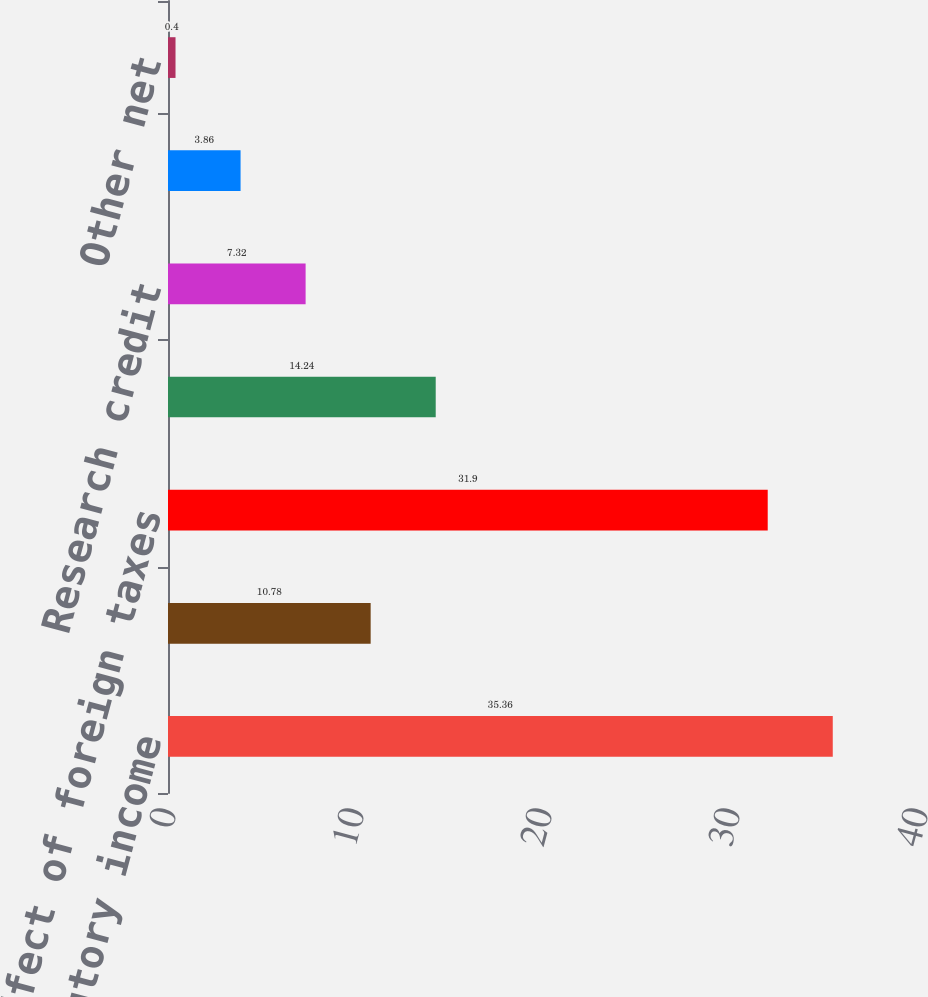<chart> <loc_0><loc_0><loc_500><loc_500><bar_chart><fcel>US federal statutory income<fcel>State income taxes net of<fcel>Effect of foreign taxes<fcel>Non-deductible acquisition<fcel>Research credit<fcel>Valuation allowance<fcel>Other net<nl><fcel>35.36<fcel>10.78<fcel>31.9<fcel>14.24<fcel>7.32<fcel>3.86<fcel>0.4<nl></chart> 